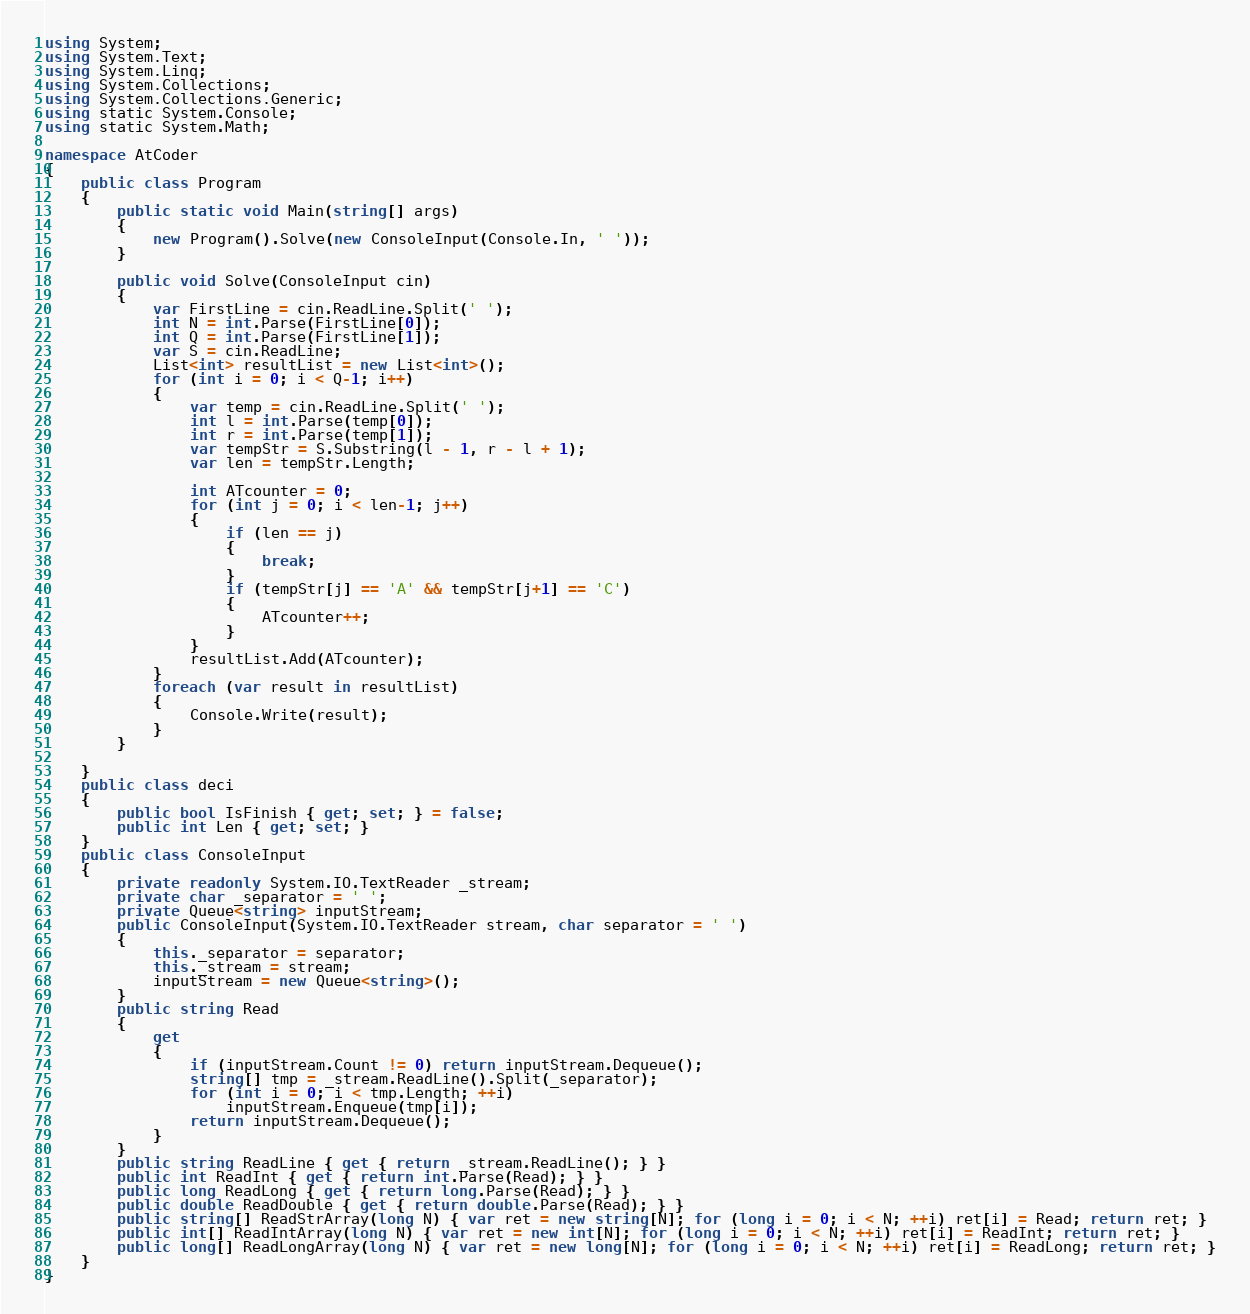<code> <loc_0><loc_0><loc_500><loc_500><_C#_>using System;
using System.Text;
using System.Linq;
using System.Collections;
using System.Collections.Generic;
using static System.Console;
using static System.Math;

namespace AtCoder
{
    public class Program
    {
        public static void Main(string[] args)
        {
            new Program().Solve(new ConsoleInput(Console.In, ' '));
        }

        public void Solve(ConsoleInput cin)
        {
            var FirstLine = cin.ReadLine.Split(' ');
            int N = int.Parse(FirstLine[0]);
            int Q = int.Parse(FirstLine[1]);
            var S = cin.ReadLine;
            List<int> resultList = new List<int>();
            for (int i = 0; i < Q-1; i++)
            {
                var temp = cin.ReadLine.Split(' ');
                int l = int.Parse(temp[0]);
                int r = int.Parse(temp[1]);
                var tempStr = S.Substring(l - 1, r - l + 1);
                var len = tempStr.Length;

                int ATcounter = 0;
                for (int j = 0; i < len-1; j++)
                {
                    if (len == j)
                    {
                        break;
                    }
                    if (tempStr[j] == 'A' && tempStr[j+1] == 'C')
                    {
                        ATcounter++;
                    }
                }
                resultList.Add(ATcounter);
            }
            foreach (var result in resultList)
            {
                Console.Write(result);
            }
        }

    }
    public class deci
    {
        public bool IsFinish { get; set; } = false;
        public int Len { get; set; }
    }
    public class ConsoleInput
    {
        private readonly System.IO.TextReader _stream;
        private char _separator = ' ';
        private Queue<string> inputStream;
        public ConsoleInput(System.IO.TextReader stream, char separator = ' ')
        {
            this._separator = separator;
            this._stream = stream;
            inputStream = new Queue<string>();
        }
        public string Read
        {
            get
            {
                if (inputStream.Count != 0) return inputStream.Dequeue();
                string[] tmp = _stream.ReadLine().Split(_separator);
                for (int i = 0; i < tmp.Length; ++i)
                    inputStream.Enqueue(tmp[i]);
                return inputStream.Dequeue();
            }
        }
        public string ReadLine { get { return _stream.ReadLine(); } }
        public int ReadInt { get { return int.Parse(Read); } }
        public long ReadLong { get { return long.Parse(Read); } }
        public double ReadDouble { get { return double.Parse(Read); } }
        public string[] ReadStrArray(long N) { var ret = new string[N]; for (long i = 0; i < N; ++i) ret[i] = Read; return ret; }
        public int[] ReadIntArray(long N) { var ret = new int[N]; for (long i = 0; i < N; ++i) ret[i] = ReadInt; return ret; }
        public long[] ReadLongArray(long N) { var ret = new long[N]; for (long i = 0; i < N; ++i) ret[i] = ReadLong; return ret; }
    }
}</code> 